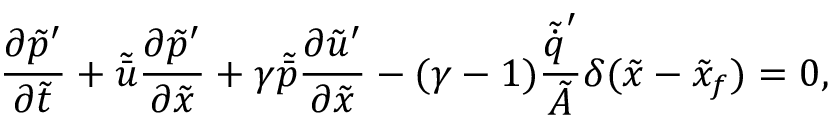Convert formula to latex. <formula><loc_0><loc_0><loc_500><loc_500>{ \frac { \partial \tilde { p } ^ { \prime } } { \partial \tilde { t } } } + \tilde { \bar { u } } { \frac { \partial \tilde { p } ^ { \prime } } { \partial \tilde { x } } } + \gamma \tilde { \bar { p } } { \frac { \partial \tilde { u } ^ { \prime } } { \partial \tilde { x } } } - ( \gamma - 1 ) \frac { \tilde { \dot { q } } ^ { \prime } } { \tilde { A } } \delta ( \tilde { x } - \tilde { x } _ { f } ) = 0 ,</formula> 